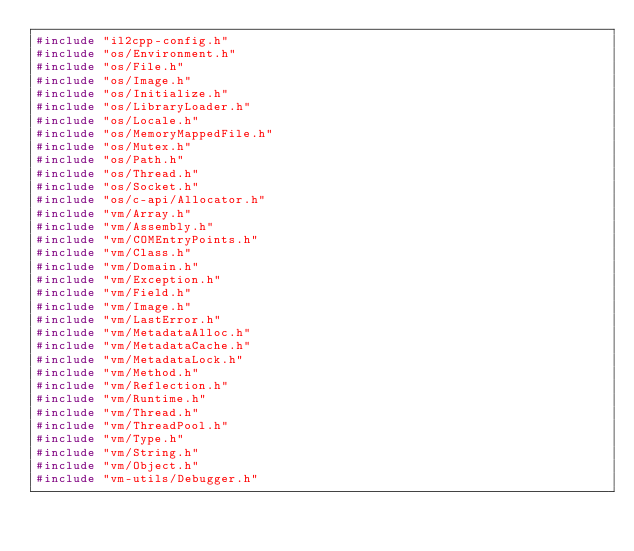<code> <loc_0><loc_0><loc_500><loc_500><_C++_>#include "il2cpp-config.h"
#include "os/Environment.h"
#include "os/File.h"
#include "os/Image.h"
#include "os/Initialize.h"
#include "os/LibraryLoader.h"
#include "os/Locale.h"
#include "os/MemoryMappedFile.h"
#include "os/Mutex.h"
#include "os/Path.h"
#include "os/Thread.h"
#include "os/Socket.h"
#include "os/c-api/Allocator.h"
#include "vm/Array.h"
#include "vm/Assembly.h"
#include "vm/COMEntryPoints.h"
#include "vm/Class.h"
#include "vm/Domain.h"
#include "vm/Exception.h"
#include "vm/Field.h"
#include "vm/Image.h"
#include "vm/LastError.h"
#include "vm/MetadataAlloc.h"
#include "vm/MetadataCache.h"
#include "vm/MetadataLock.h"
#include "vm/Method.h"
#include "vm/Reflection.h"
#include "vm/Runtime.h"
#include "vm/Thread.h"
#include "vm/ThreadPool.h"
#include "vm/Type.h"
#include "vm/String.h"
#include "vm/Object.h"
#include "vm-utils/Debugger.h"</code> 